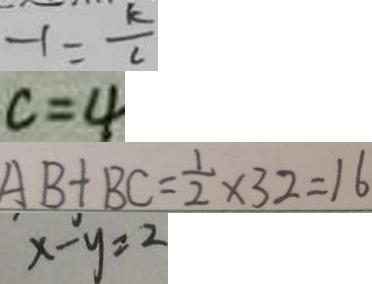<formula> <loc_0><loc_0><loc_500><loc_500>- 1 = \frac { k } { c } 
 c = 4 
 A B + B C = \frac { 1 } { 2 } \times 3 2 = 1 6 
 x - y = 2</formula> 